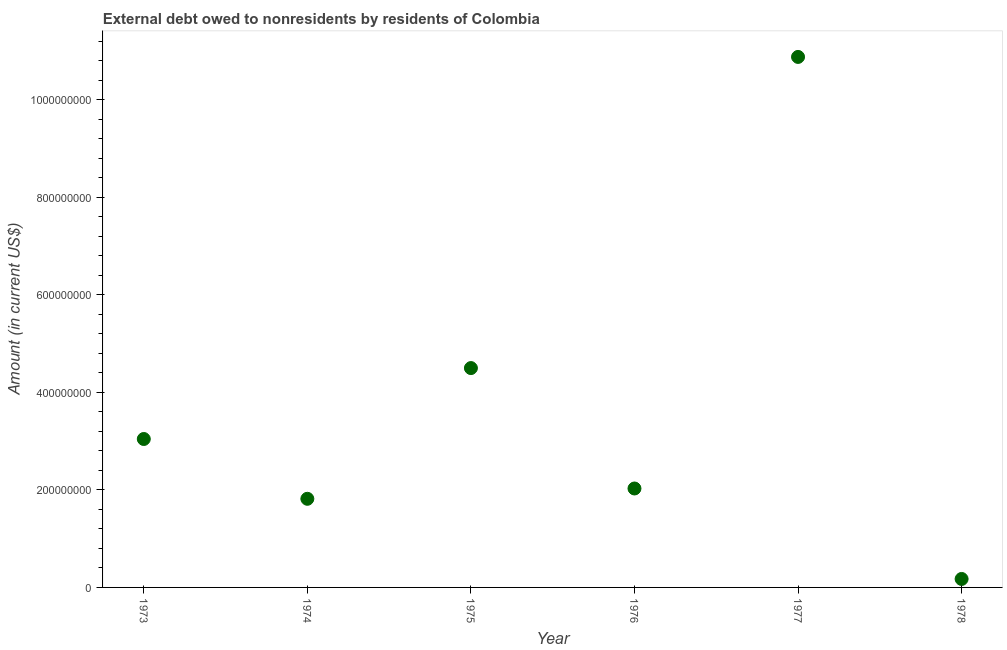What is the debt in 1974?
Offer a terse response. 1.82e+08. Across all years, what is the maximum debt?
Keep it short and to the point. 1.09e+09. Across all years, what is the minimum debt?
Ensure brevity in your answer.  1.74e+07. In which year was the debt maximum?
Provide a succinct answer. 1977. In which year was the debt minimum?
Give a very brief answer. 1978. What is the sum of the debt?
Your answer should be compact. 2.24e+09. What is the difference between the debt in 1973 and 1975?
Provide a short and direct response. -1.45e+08. What is the average debt per year?
Your answer should be very brief. 3.74e+08. What is the median debt?
Your answer should be compact. 2.54e+08. In how many years, is the debt greater than 400000000 US$?
Your response must be concise. 2. What is the ratio of the debt in 1977 to that in 1978?
Offer a terse response. 62.66. Is the difference between the debt in 1976 and 1977 greater than the difference between any two years?
Provide a succinct answer. No. What is the difference between the highest and the second highest debt?
Provide a short and direct response. 6.38e+08. Is the sum of the debt in 1975 and 1976 greater than the maximum debt across all years?
Keep it short and to the point. No. What is the difference between the highest and the lowest debt?
Provide a short and direct response. 1.07e+09. In how many years, is the debt greater than the average debt taken over all years?
Ensure brevity in your answer.  2. How many dotlines are there?
Offer a very short reply. 1. How many years are there in the graph?
Your answer should be very brief. 6. What is the difference between two consecutive major ticks on the Y-axis?
Provide a succinct answer. 2.00e+08. Are the values on the major ticks of Y-axis written in scientific E-notation?
Keep it short and to the point. No. Does the graph contain any zero values?
Your response must be concise. No. Does the graph contain grids?
Keep it short and to the point. No. What is the title of the graph?
Keep it short and to the point. External debt owed to nonresidents by residents of Colombia. What is the Amount (in current US$) in 1973?
Your response must be concise. 3.04e+08. What is the Amount (in current US$) in 1974?
Your answer should be very brief. 1.82e+08. What is the Amount (in current US$) in 1975?
Provide a succinct answer. 4.50e+08. What is the Amount (in current US$) in 1976?
Ensure brevity in your answer.  2.03e+08. What is the Amount (in current US$) in 1977?
Keep it short and to the point. 1.09e+09. What is the Amount (in current US$) in 1978?
Provide a succinct answer. 1.74e+07. What is the difference between the Amount (in current US$) in 1973 and 1974?
Your response must be concise. 1.23e+08. What is the difference between the Amount (in current US$) in 1973 and 1975?
Your answer should be compact. -1.45e+08. What is the difference between the Amount (in current US$) in 1973 and 1976?
Offer a very short reply. 1.01e+08. What is the difference between the Amount (in current US$) in 1973 and 1977?
Offer a terse response. -7.83e+08. What is the difference between the Amount (in current US$) in 1973 and 1978?
Your answer should be very brief. 2.87e+08. What is the difference between the Amount (in current US$) in 1974 and 1975?
Keep it short and to the point. -2.68e+08. What is the difference between the Amount (in current US$) in 1974 and 1976?
Your answer should be compact. -2.11e+07. What is the difference between the Amount (in current US$) in 1974 and 1977?
Give a very brief answer. -9.06e+08. What is the difference between the Amount (in current US$) in 1974 and 1978?
Your response must be concise. 1.64e+08. What is the difference between the Amount (in current US$) in 1975 and 1976?
Your answer should be very brief. 2.47e+08. What is the difference between the Amount (in current US$) in 1975 and 1977?
Provide a succinct answer. -6.38e+08. What is the difference between the Amount (in current US$) in 1975 and 1978?
Offer a very short reply. 4.32e+08. What is the difference between the Amount (in current US$) in 1976 and 1977?
Make the answer very short. -8.85e+08. What is the difference between the Amount (in current US$) in 1976 and 1978?
Keep it short and to the point. 1.86e+08. What is the difference between the Amount (in current US$) in 1977 and 1978?
Ensure brevity in your answer.  1.07e+09. What is the ratio of the Amount (in current US$) in 1973 to that in 1974?
Keep it short and to the point. 1.68. What is the ratio of the Amount (in current US$) in 1973 to that in 1975?
Provide a short and direct response. 0.68. What is the ratio of the Amount (in current US$) in 1973 to that in 1977?
Your response must be concise. 0.28. What is the ratio of the Amount (in current US$) in 1973 to that in 1978?
Provide a succinct answer. 17.53. What is the ratio of the Amount (in current US$) in 1974 to that in 1975?
Your answer should be compact. 0.4. What is the ratio of the Amount (in current US$) in 1974 to that in 1976?
Make the answer very short. 0.9. What is the ratio of the Amount (in current US$) in 1974 to that in 1977?
Keep it short and to the point. 0.17. What is the ratio of the Amount (in current US$) in 1974 to that in 1978?
Your response must be concise. 10.47. What is the ratio of the Amount (in current US$) in 1975 to that in 1976?
Give a very brief answer. 2.22. What is the ratio of the Amount (in current US$) in 1975 to that in 1977?
Provide a succinct answer. 0.41. What is the ratio of the Amount (in current US$) in 1975 to that in 1978?
Keep it short and to the point. 25.91. What is the ratio of the Amount (in current US$) in 1976 to that in 1977?
Keep it short and to the point. 0.19. What is the ratio of the Amount (in current US$) in 1976 to that in 1978?
Provide a succinct answer. 11.69. What is the ratio of the Amount (in current US$) in 1977 to that in 1978?
Provide a succinct answer. 62.66. 